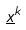<formula> <loc_0><loc_0><loc_500><loc_500>\underline { x } ^ { k }</formula> 